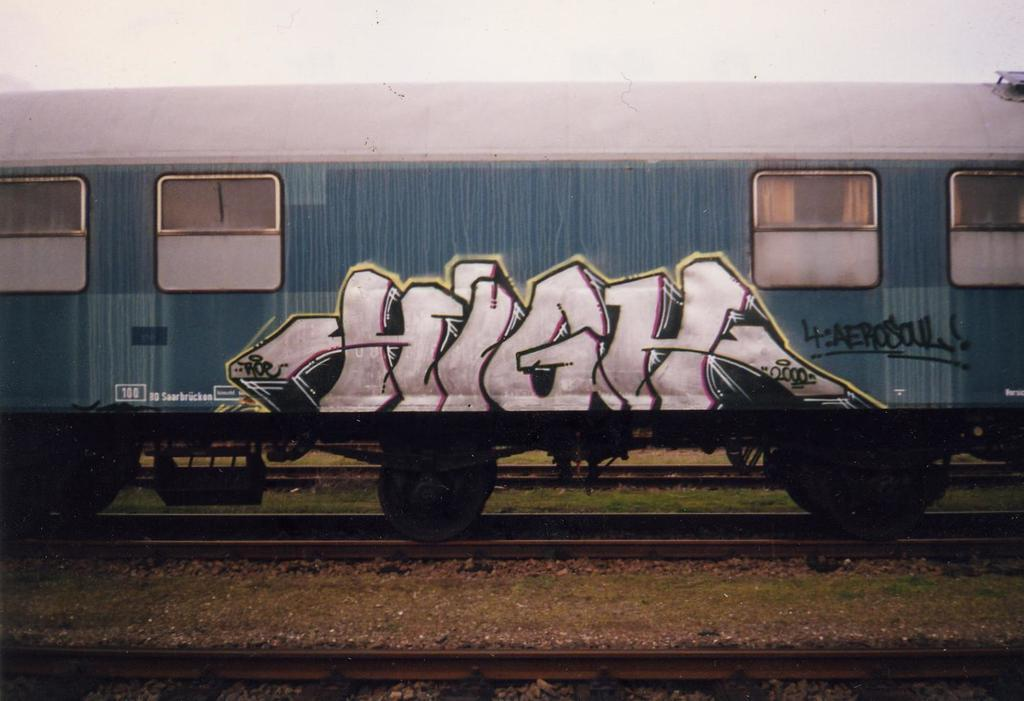<image>
Summarize the visual content of the image. A blue train with a graffiti tag on it that says High. 